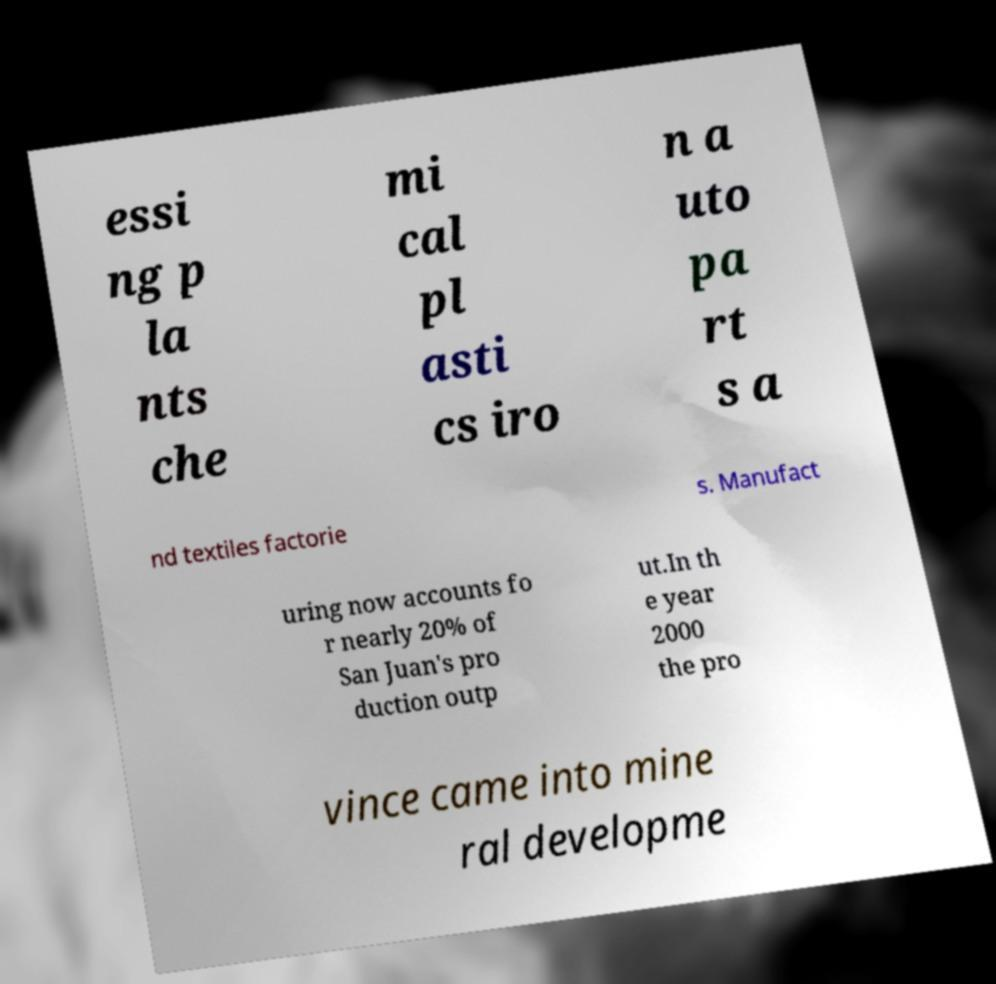What messages or text are displayed in this image? I need them in a readable, typed format. essi ng p la nts che mi cal pl asti cs iro n a uto pa rt s a nd textiles factorie s. Manufact uring now accounts fo r nearly 20% of San Juan's pro duction outp ut.In th e year 2000 the pro vince came into mine ral developme 